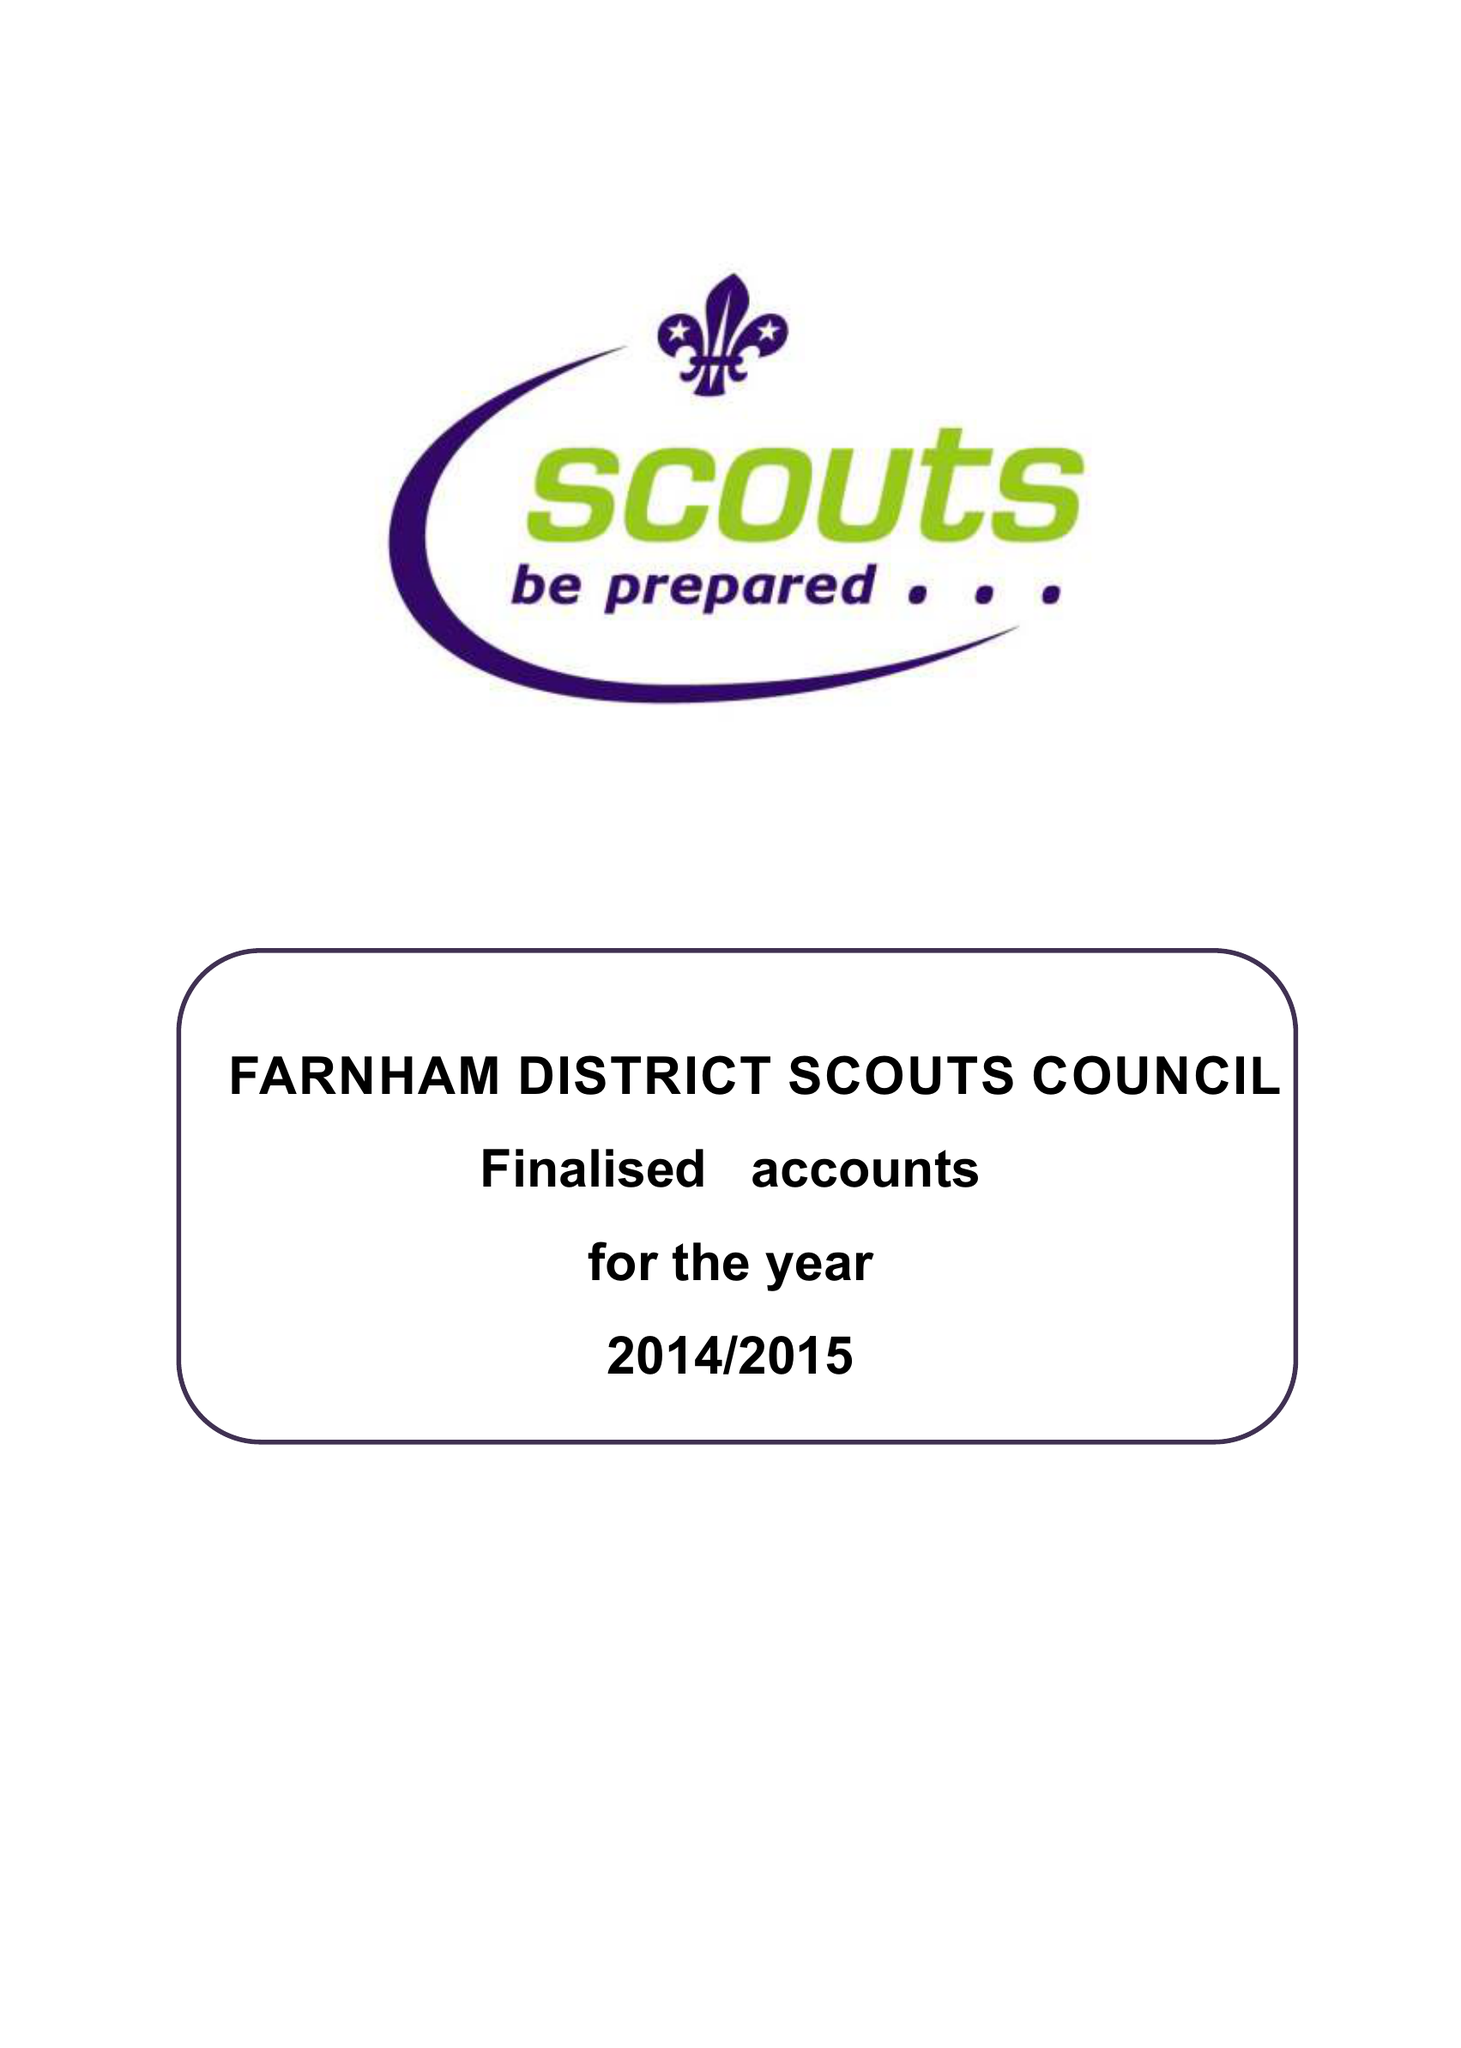What is the value for the address__post_town?
Answer the question using a single word or phrase. FARNHAM 